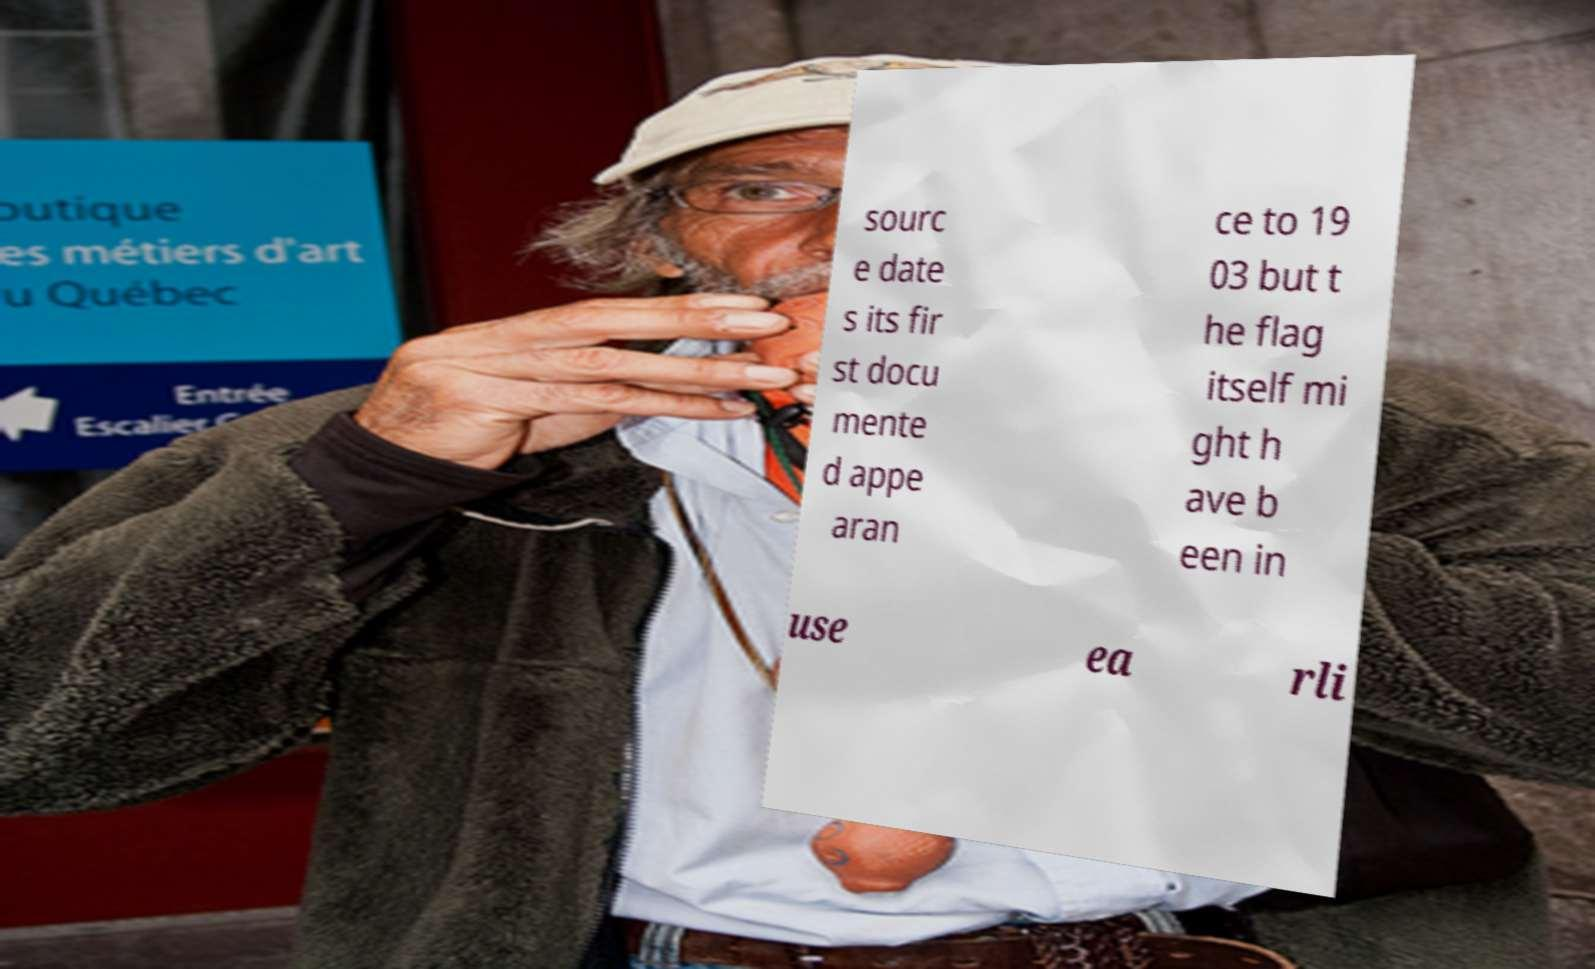Please identify and transcribe the text found in this image. sourc e date s its fir st docu mente d appe aran ce to 19 03 but t he flag itself mi ght h ave b een in use ea rli 